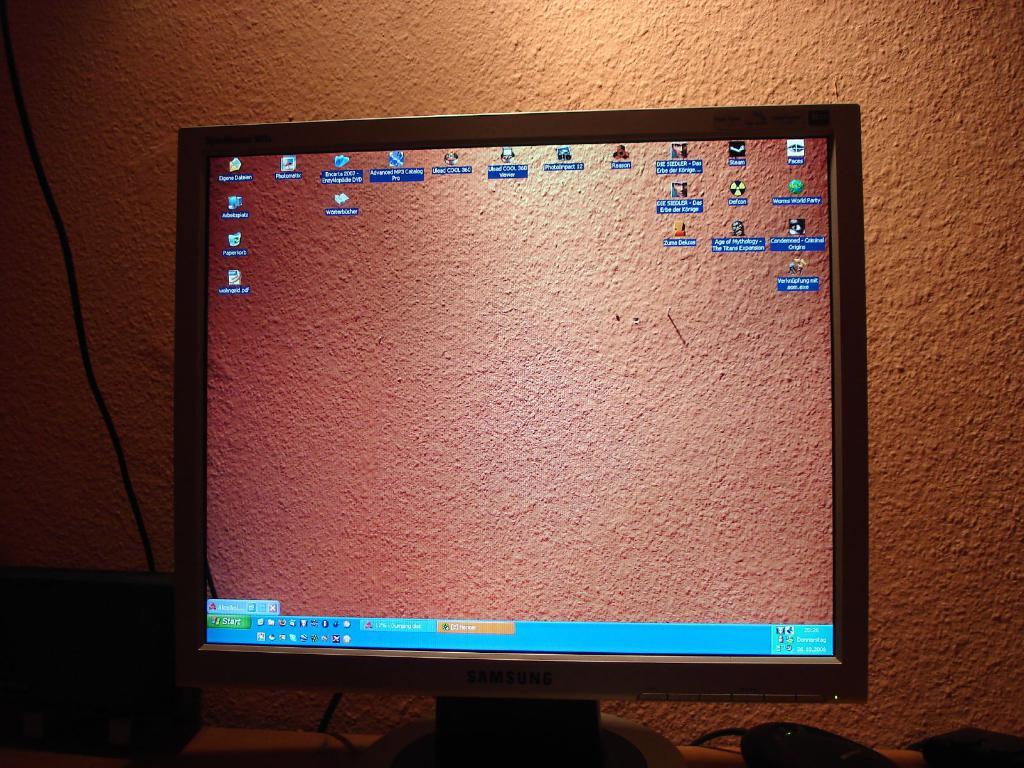What does the green button on the bottom left say?
Provide a short and direct response. Start. This is computer display?
Keep it short and to the point. Answering does not require reading text in the image. 